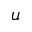<formula> <loc_0><loc_0><loc_500><loc_500>u</formula> 